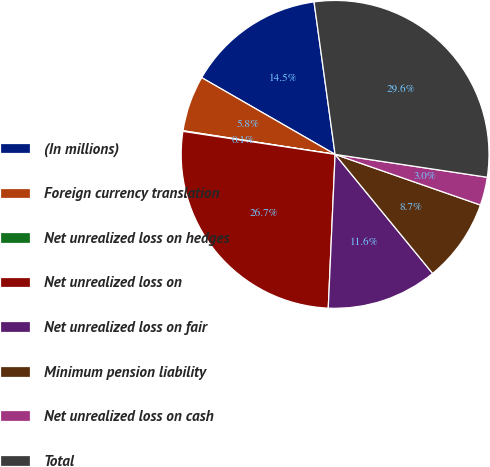<chart> <loc_0><loc_0><loc_500><loc_500><pie_chart><fcel>(In millions)<fcel>Foreign currency translation<fcel>Net unrealized loss on hedges<fcel>Net unrealized loss on<fcel>Net unrealized loss on fair<fcel>Minimum pension liability<fcel>Net unrealized loss on cash<fcel>Total<nl><fcel>14.51%<fcel>5.85%<fcel>0.07%<fcel>26.68%<fcel>11.63%<fcel>8.74%<fcel>2.96%<fcel>29.56%<nl></chart> 